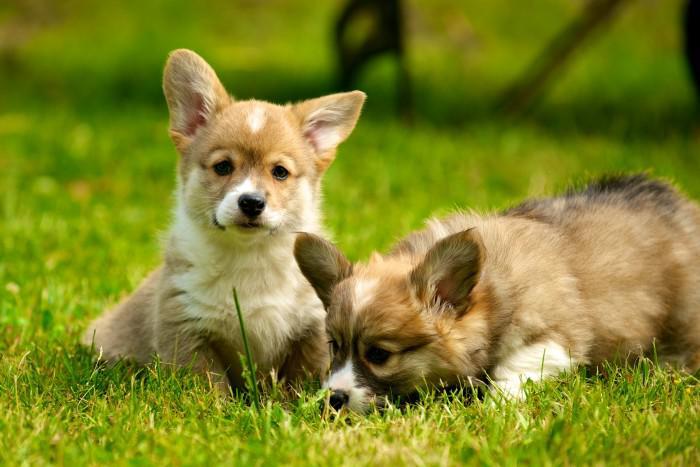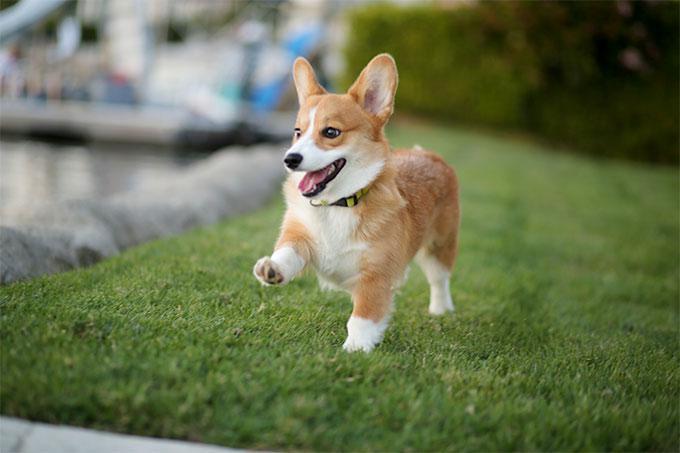The first image is the image on the left, the second image is the image on the right. Examine the images to the left and right. Is the description "Only one of the dogs has its mouth open." accurate? Answer yes or no. Yes. The first image is the image on the left, the second image is the image on the right. Assess this claim about the two images: "There are two dogs in the left image.". Correct or not? Answer yes or no. Yes. 